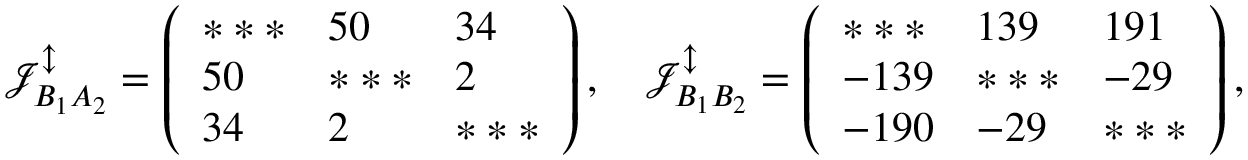Convert formula to latex. <formula><loc_0><loc_0><loc_500><loc_500>\mathcal { J } _ { B _ { 1 } A _ { 2 } } ^ { \updownarrow } = \left ( \begin{array} { l l l } { * * * } & { 5 0 } & { 3 4 } \\ { 5 0 } & { * * * } & { 2 } \\ { 3 4 } & { 2 } & { * * * } \end{array} \right ) , \quad \mathcal { J } _ { B _ { 1 } B _ { 2 } } ^ { \updownarrow } = \left ( \begin{array} { l l l } { * * * } & { 1 3 9 } & { 1 9 1 } \\ { - 1 3 9 } & { * * * } & { - 2 9 } \\ { - 1 9 0 } & { - 2 9 } & { * * * } \end{array} \right ) ,</formula> 